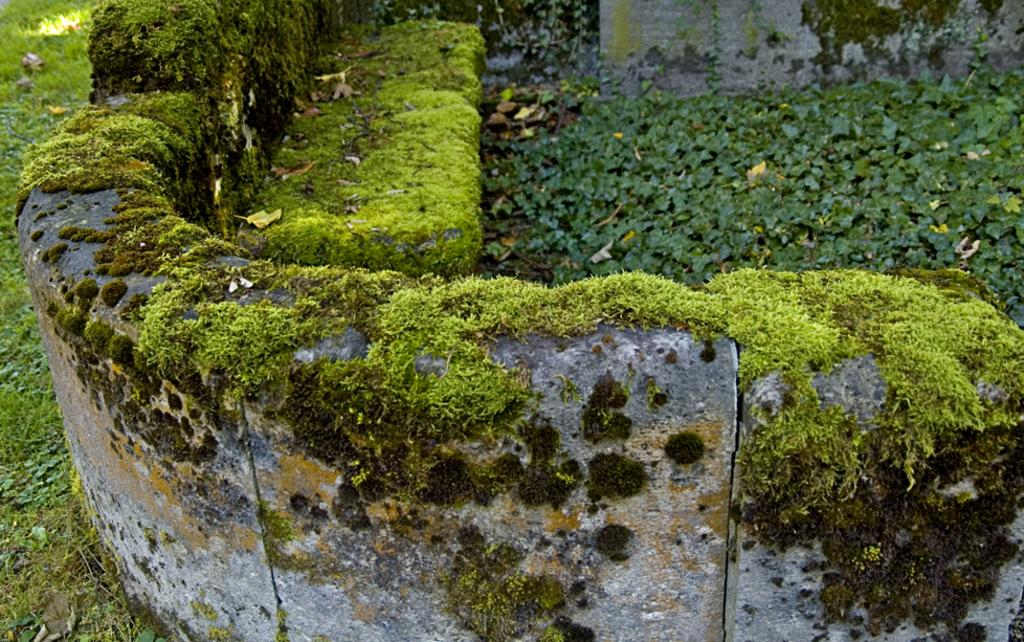What is one of the main features of the image? There is a wall in the image. What is growing on the wall? There is grass and algae on the wall. What is present on the ground to the left of the wall? There is grass on the ground to the left of the wall. What can be seen to the right of the wall? There are plants to the right of the wall. How many pages of a book are visible in the image? There are no pages of a book present in the image. What color are the dad's toes in the image? There is no dad or toes visible in the image. 